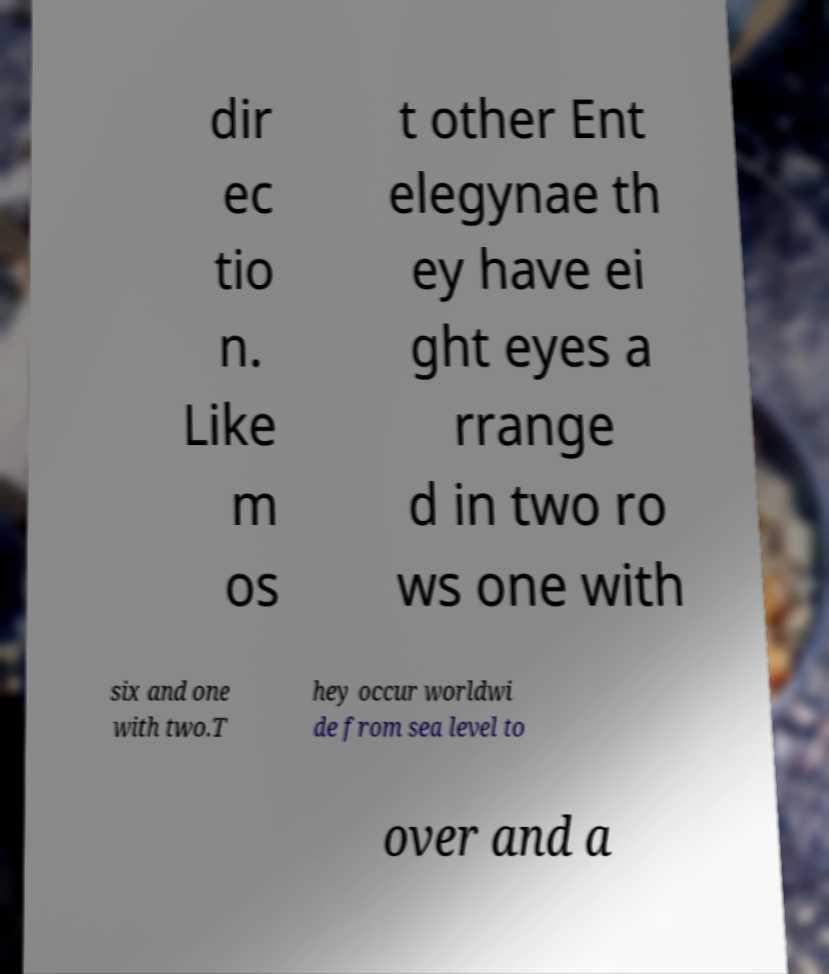What messages or text are displayed in this image? I need them in a readable, typed format. dir ec tio n. Like m os t other Ent elegynae th ey have ei ght eyes a rrange d in two ro ws one with six and one with two.T hey occur worldwi de from sea level to over and a 